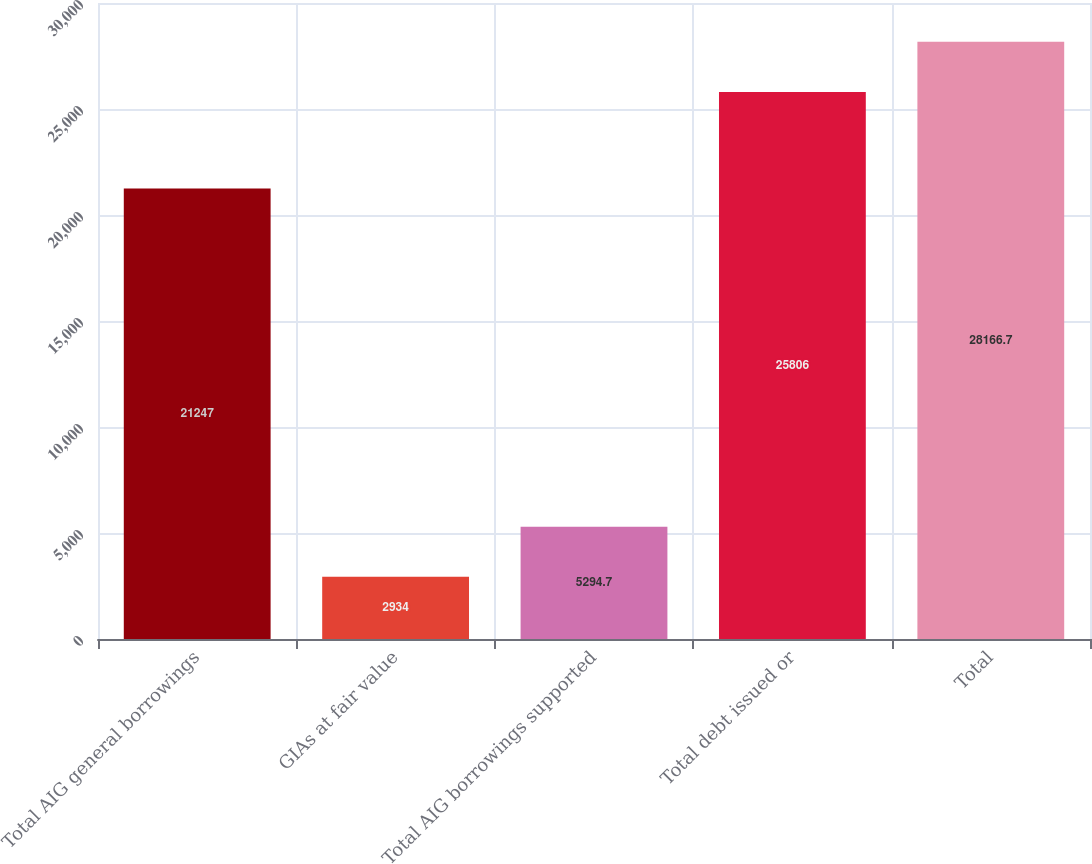Convert chart. <chart><loc_0><loc_0><loc_500><loc_500><bar_chart><fcel>Total AIG general borrowings<fcel>GIAs at fair value<fcel>Total AIG borrowings supported<fcel>Total debt issued or<fcel>Total<nl><fcel>21247<fcel>2934<fcel>5294.7<fcel>25806<fcel>28166.7<nl></chart> 